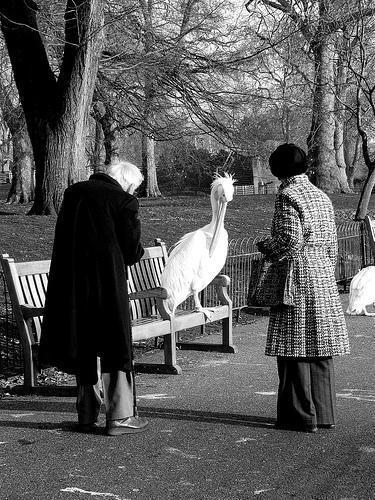How many people are there?
Give a very brief answer. 2. How many people are shown?
Give a very brief answer. 2. How many benches are shown?
Give a very brief answer. 1. 